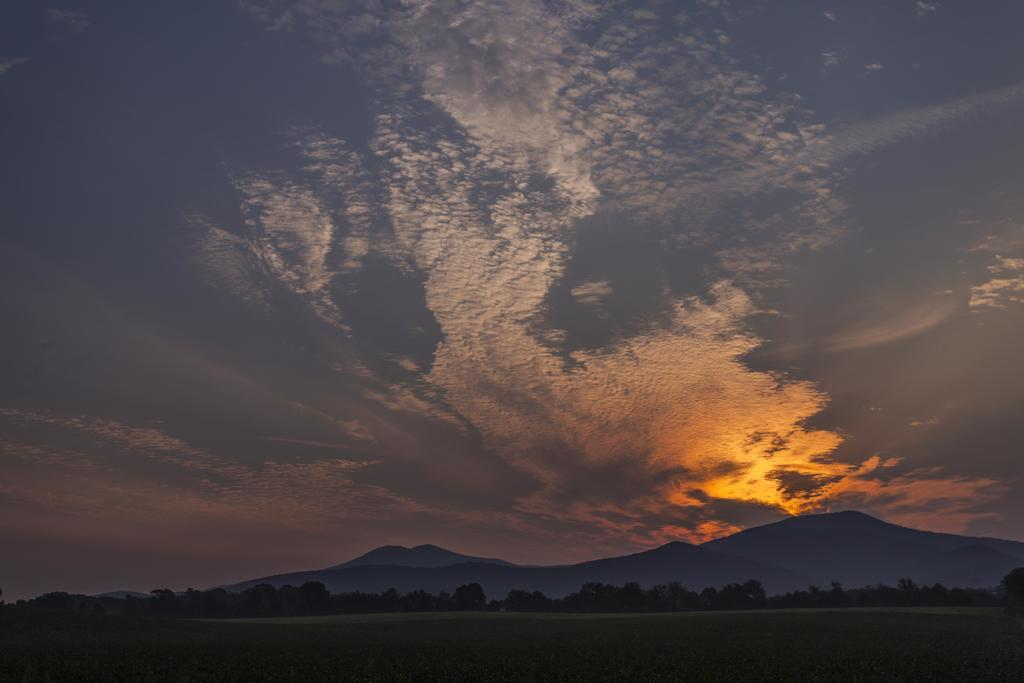What type of vegetation can be seen in the image? There are trees in the image. What geographical features are present in the image? There are hills in the image. What can be seen in the sky in the image? There are clouds in the image. Can you tell me the name of the nation depicted in the image? There is no specific nation depicted in the image; it features trees, hills, and clouds. What type of watch is visible on the tree in the image? There is no watch present in the image; it features trees, hills, and clouds. 